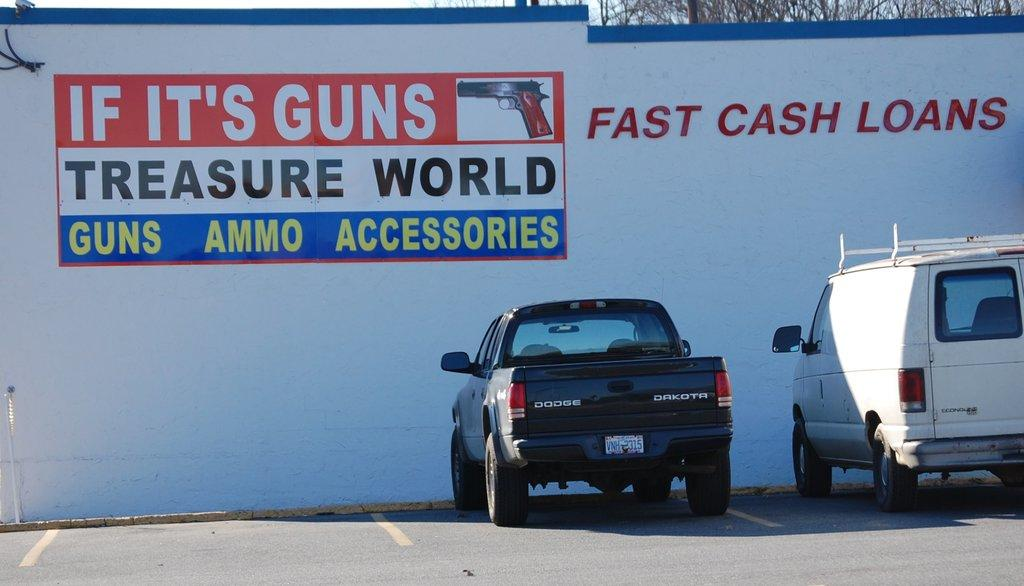<image>
Describe the image concisely. A sign for a shop that sells guns on a wall in a car park. 